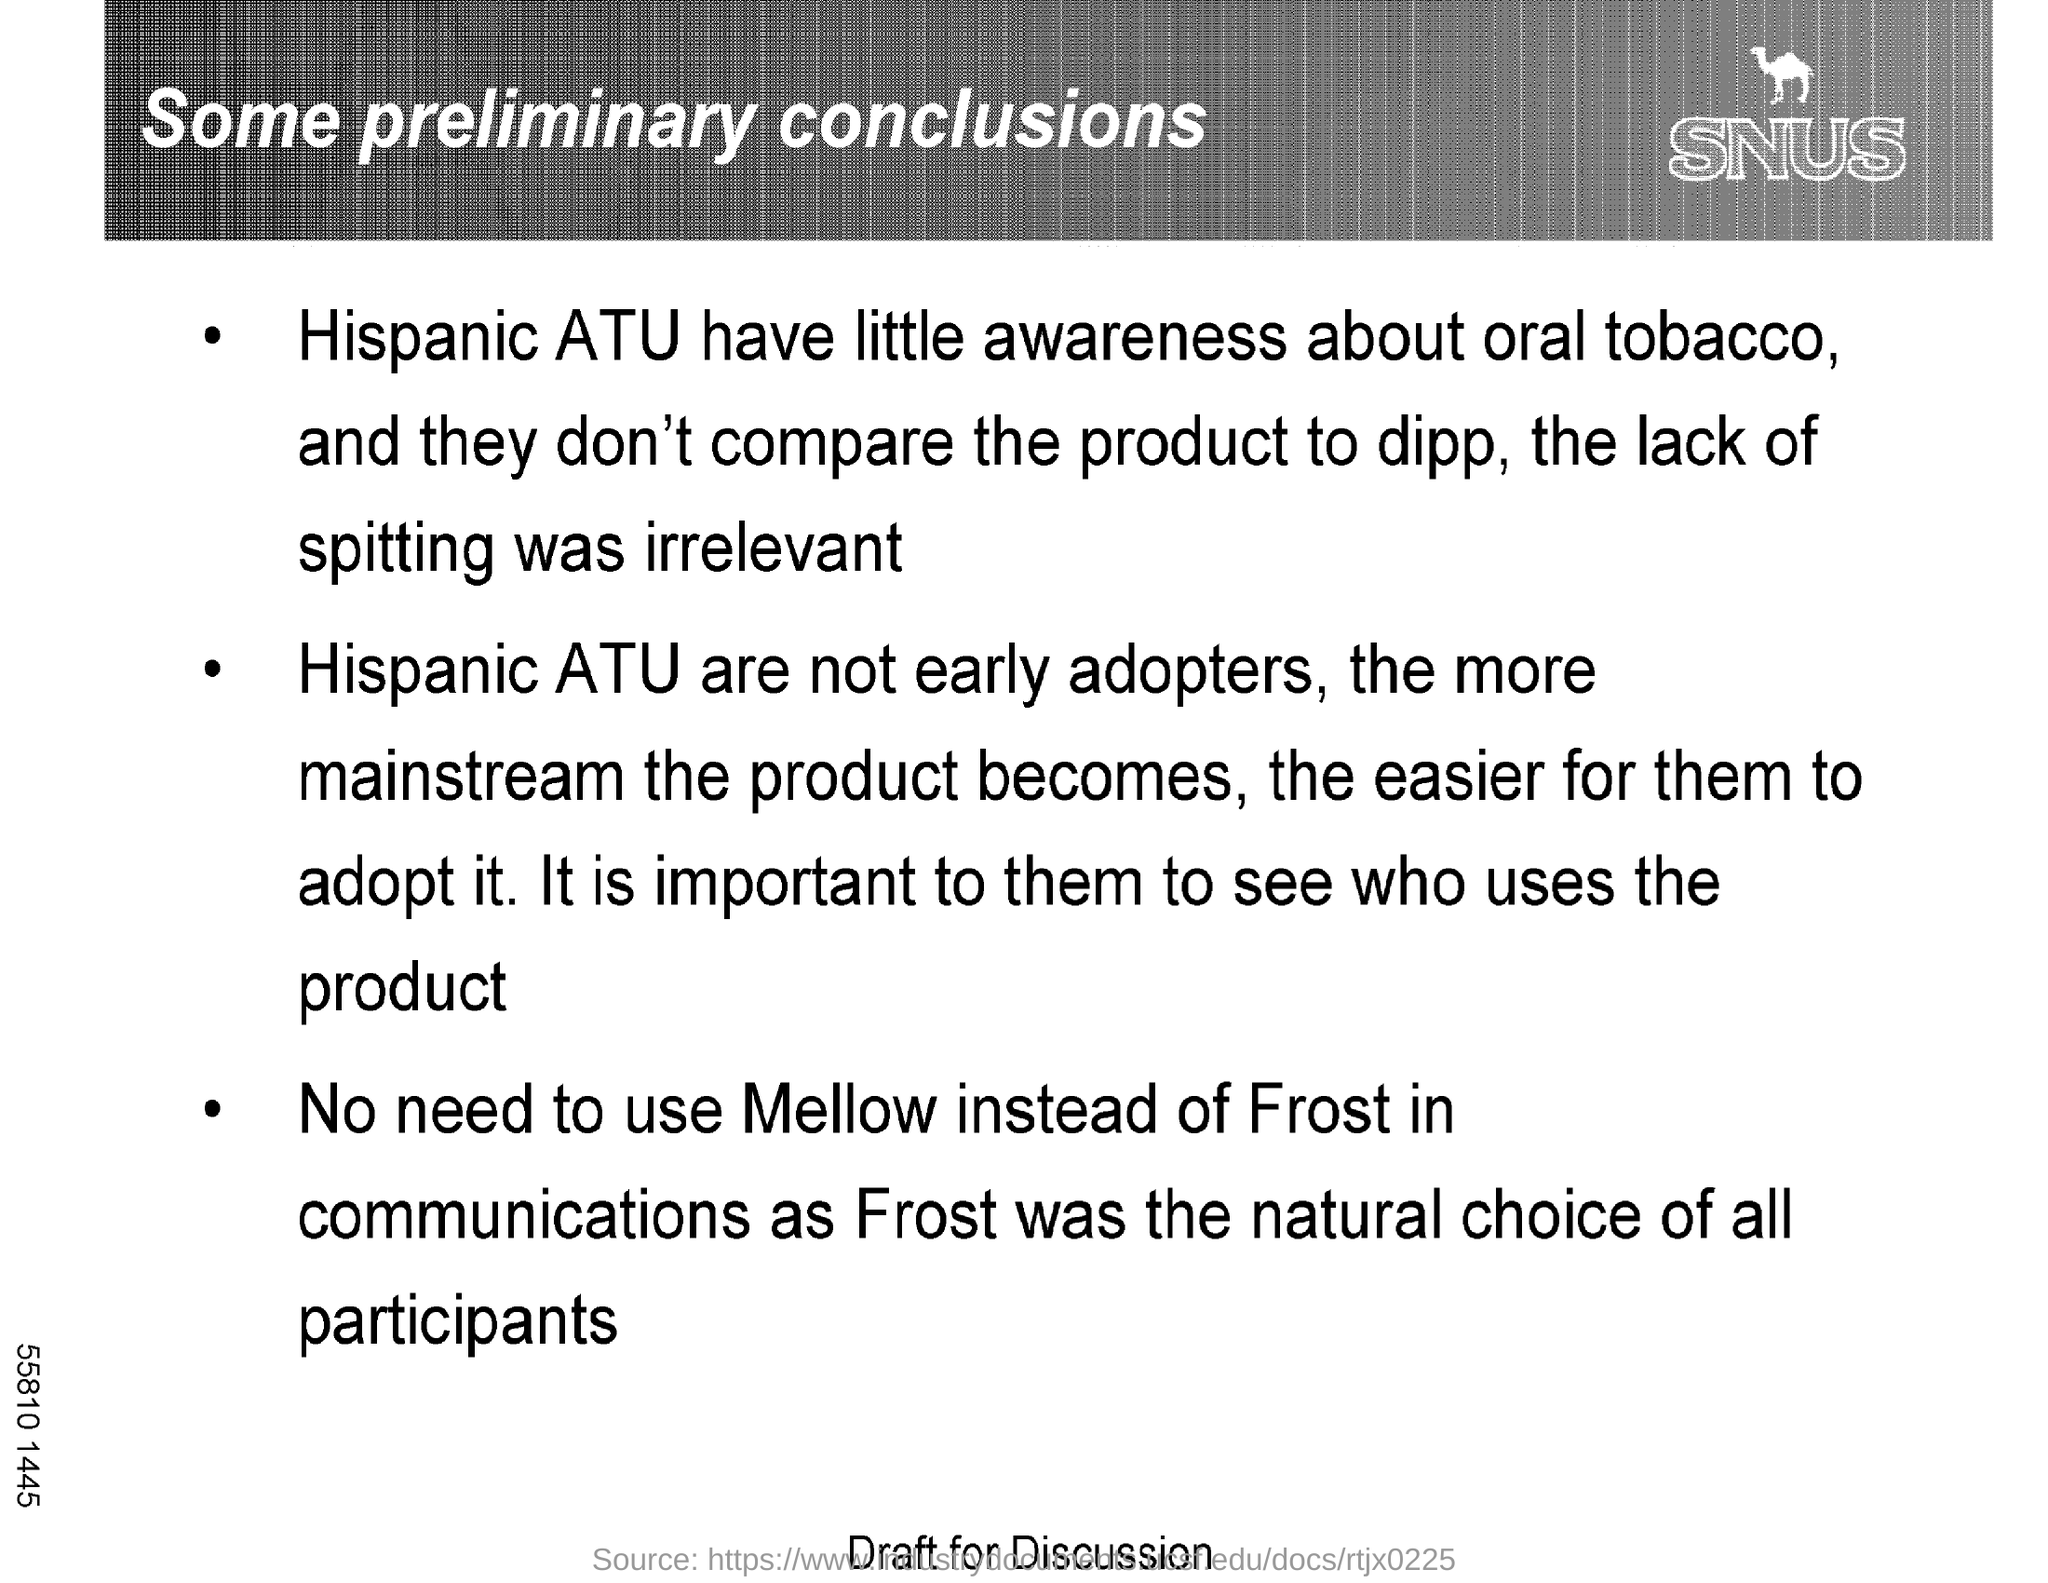What is the text written below the image?
Ensure brevity in your answer.  Snus. What is the title of the document?
Your answer should be compact. SOME PRELIMINARY CONCLUSIONS. 